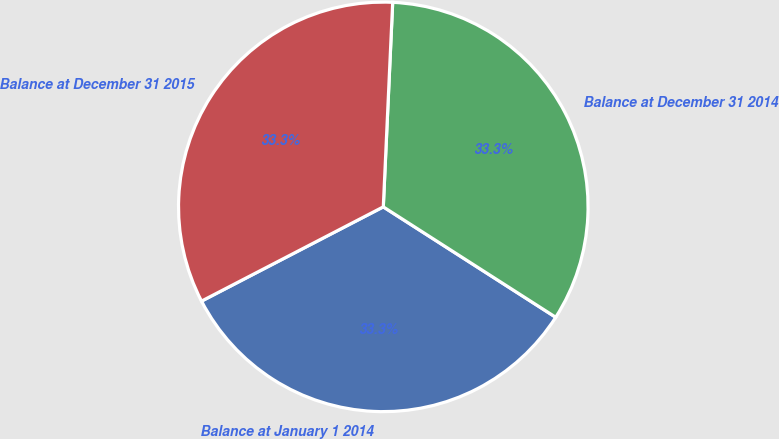Convert chart to OTSL. <chart><loc_0><loc_0><loc_500><loc_500><pie_chart><fcel>Balance at January 1 2014<fcel>Balance at December 31 2014<fcel>Balance at December 31 2015<nl><fcel>33.32%<fcel>33.33%<fcel>33.34%<nl></chart> 